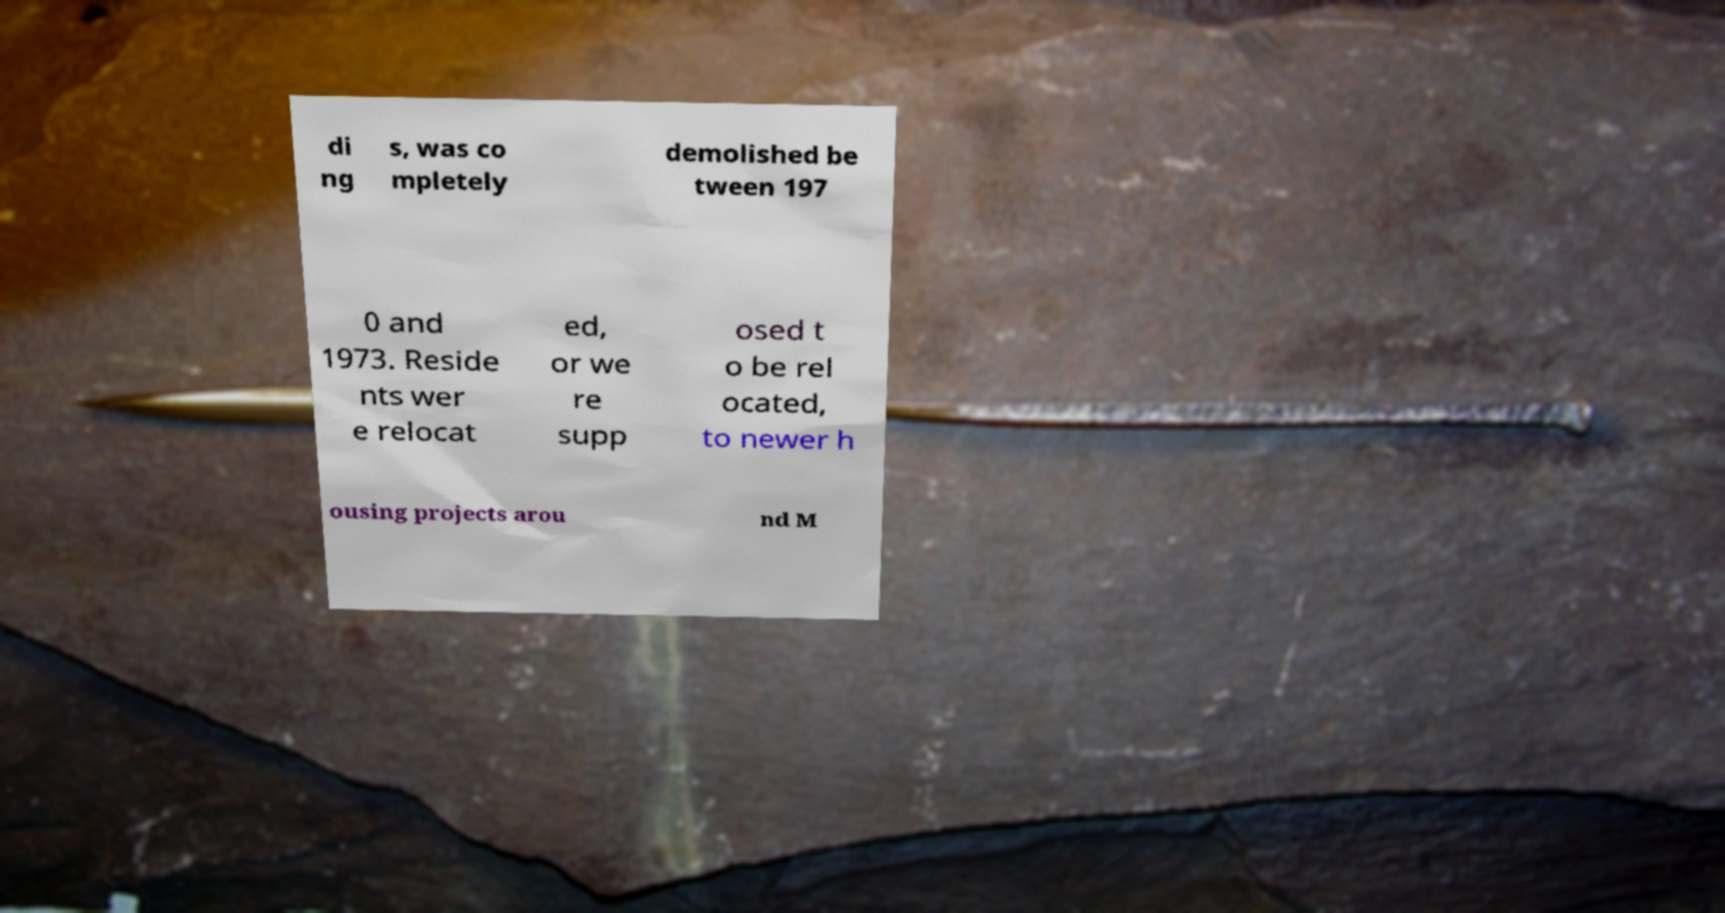I need the written content from this picture converted into text. Can you do that? di ng s, was co mpletely demolished be tween 197 0 and 1973. Reside nts wer e relocat ed, or we re supp osed t o be rel ocated, to newer h ousing projects arou nd M 